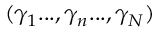<formula> <loc_0><loc_0><loc_500><loc_500>( \gamma _ { 1 } \dots , \gamma _ { n } \dots , \gamma _ { N } )</formula> 